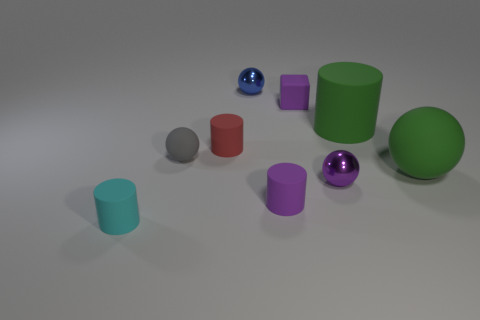Are there any spheres that are in front of the big green rubber thing behind the sphere that is left of the small red cylinder?
Your response must be concise. Yes. There is a purple rubber object that is in front of the tiny purple shiny ball; is its shape the same as the tiny cyan object?
Offer a terse response. Yes. Is the number of tiny balls in front of the small rubber sphere greater than the number of big blue metal cylinders?
Make the answer very short. Yes. Do the big cylinder right of the tiny purple metal sphere and the large sphere have the same color?
Keep it short and to the point. Yes. Is there any other thing of the same color as the small matte sphere?
Offer a very short reply. No. What color is the rubber ball to the right of the tiny purple thing that is behind the large thing behind the tiny red thing?
Provide a short and direct response. Green. Do the red cylinder and the green rubber cylinder have the same size?
Provide a succinct answer. No. What number of green rubber objects have the same size as the cyan cylinder?
Keep it short and to the point. 0. What is the shape of the large thing that is the same color as the large cylinder?
Give a very brief answer. Sphere. Does the cylinder behind the red thing have the same material as the tiny ball that is behind the small red matte cylinder?
Keep it short and to the point. No. 